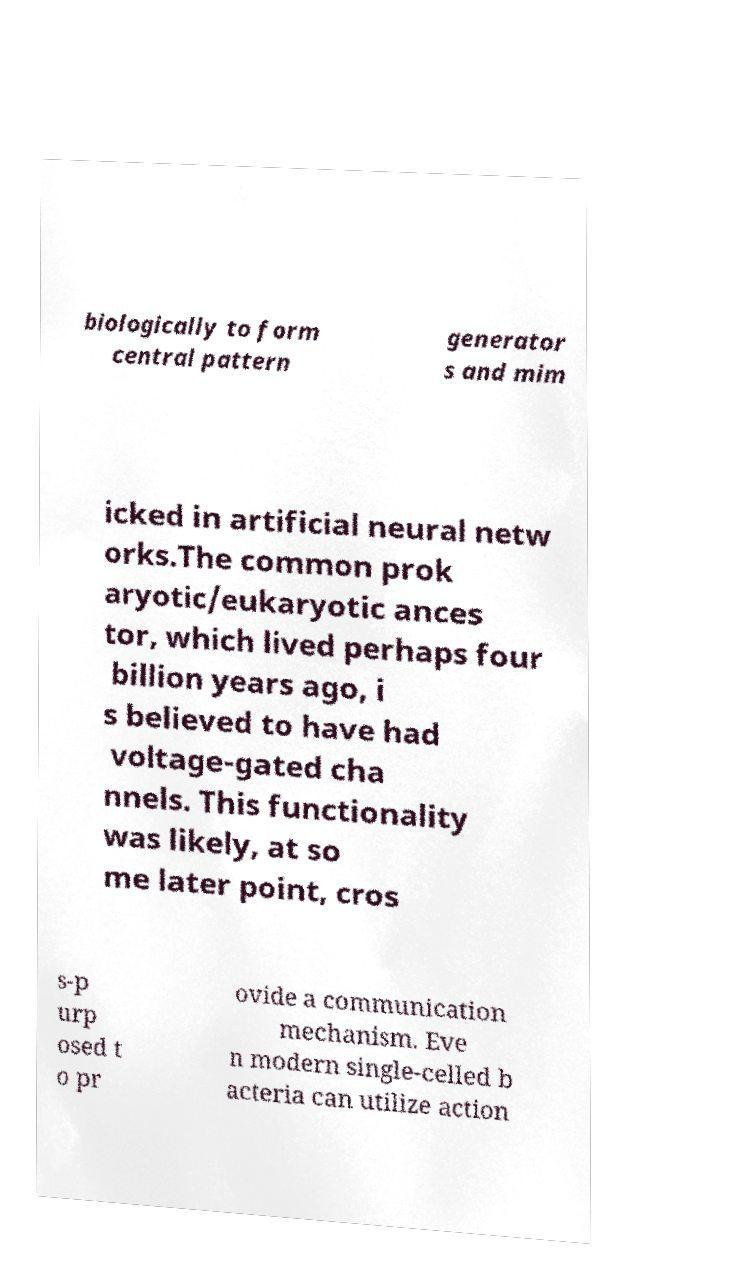What messages or text are displayed in this image? I need them in a readable, typed format. biologically to form central pattern generator s and mim icked in artificial neural netw orks.The common prok aryotic/eukaryotic ances tor, which lived perhaps four billion years ago, i s believed to have had voltage-gated cha nnels. This functionality was likely, at so me later point, cros s-p urp osed t o pr ovide a communication mechanism. Eve n modern single-celled b acteria can utilize action 